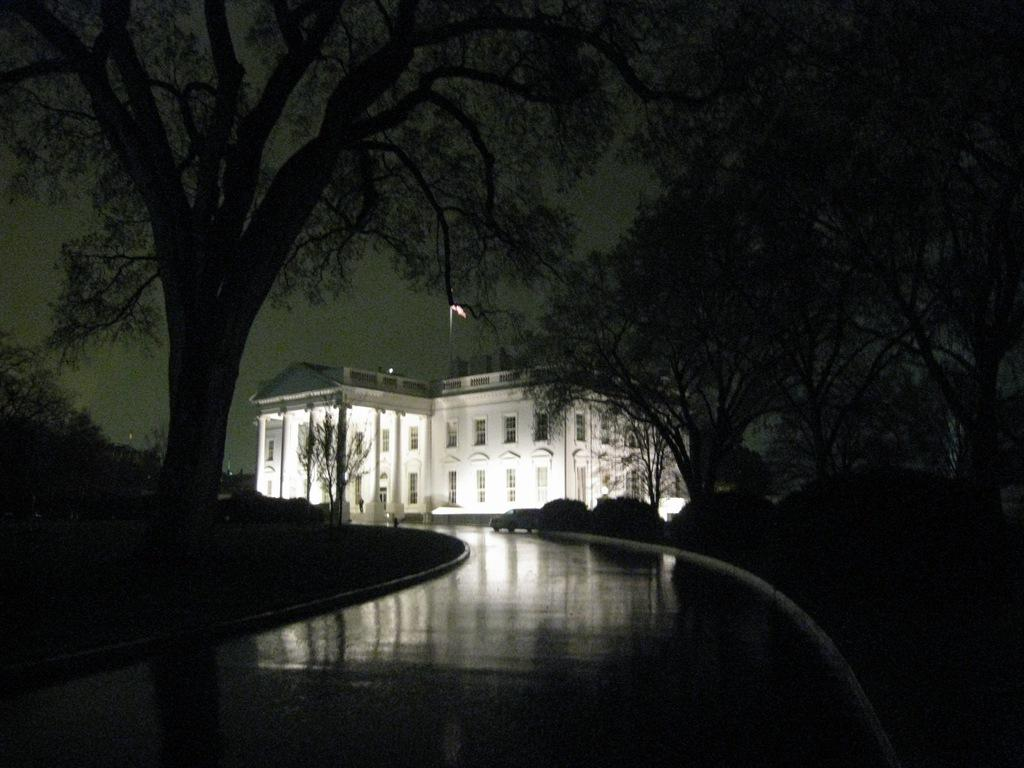What type of natural elements can be seen in the image? There are trees in the image. What type of structure is visible in the image? There is a white-colored building in the image. Can you describe the lighting conditions in the image? The image appears to be slightly dark. Where is the dad sitting on the shelf in the image? There is no dad or shelf present in the image. How does the digestion process affect the trees in the image? There is no information about digestion in the image, and the trees are not affected by any digestion process. 